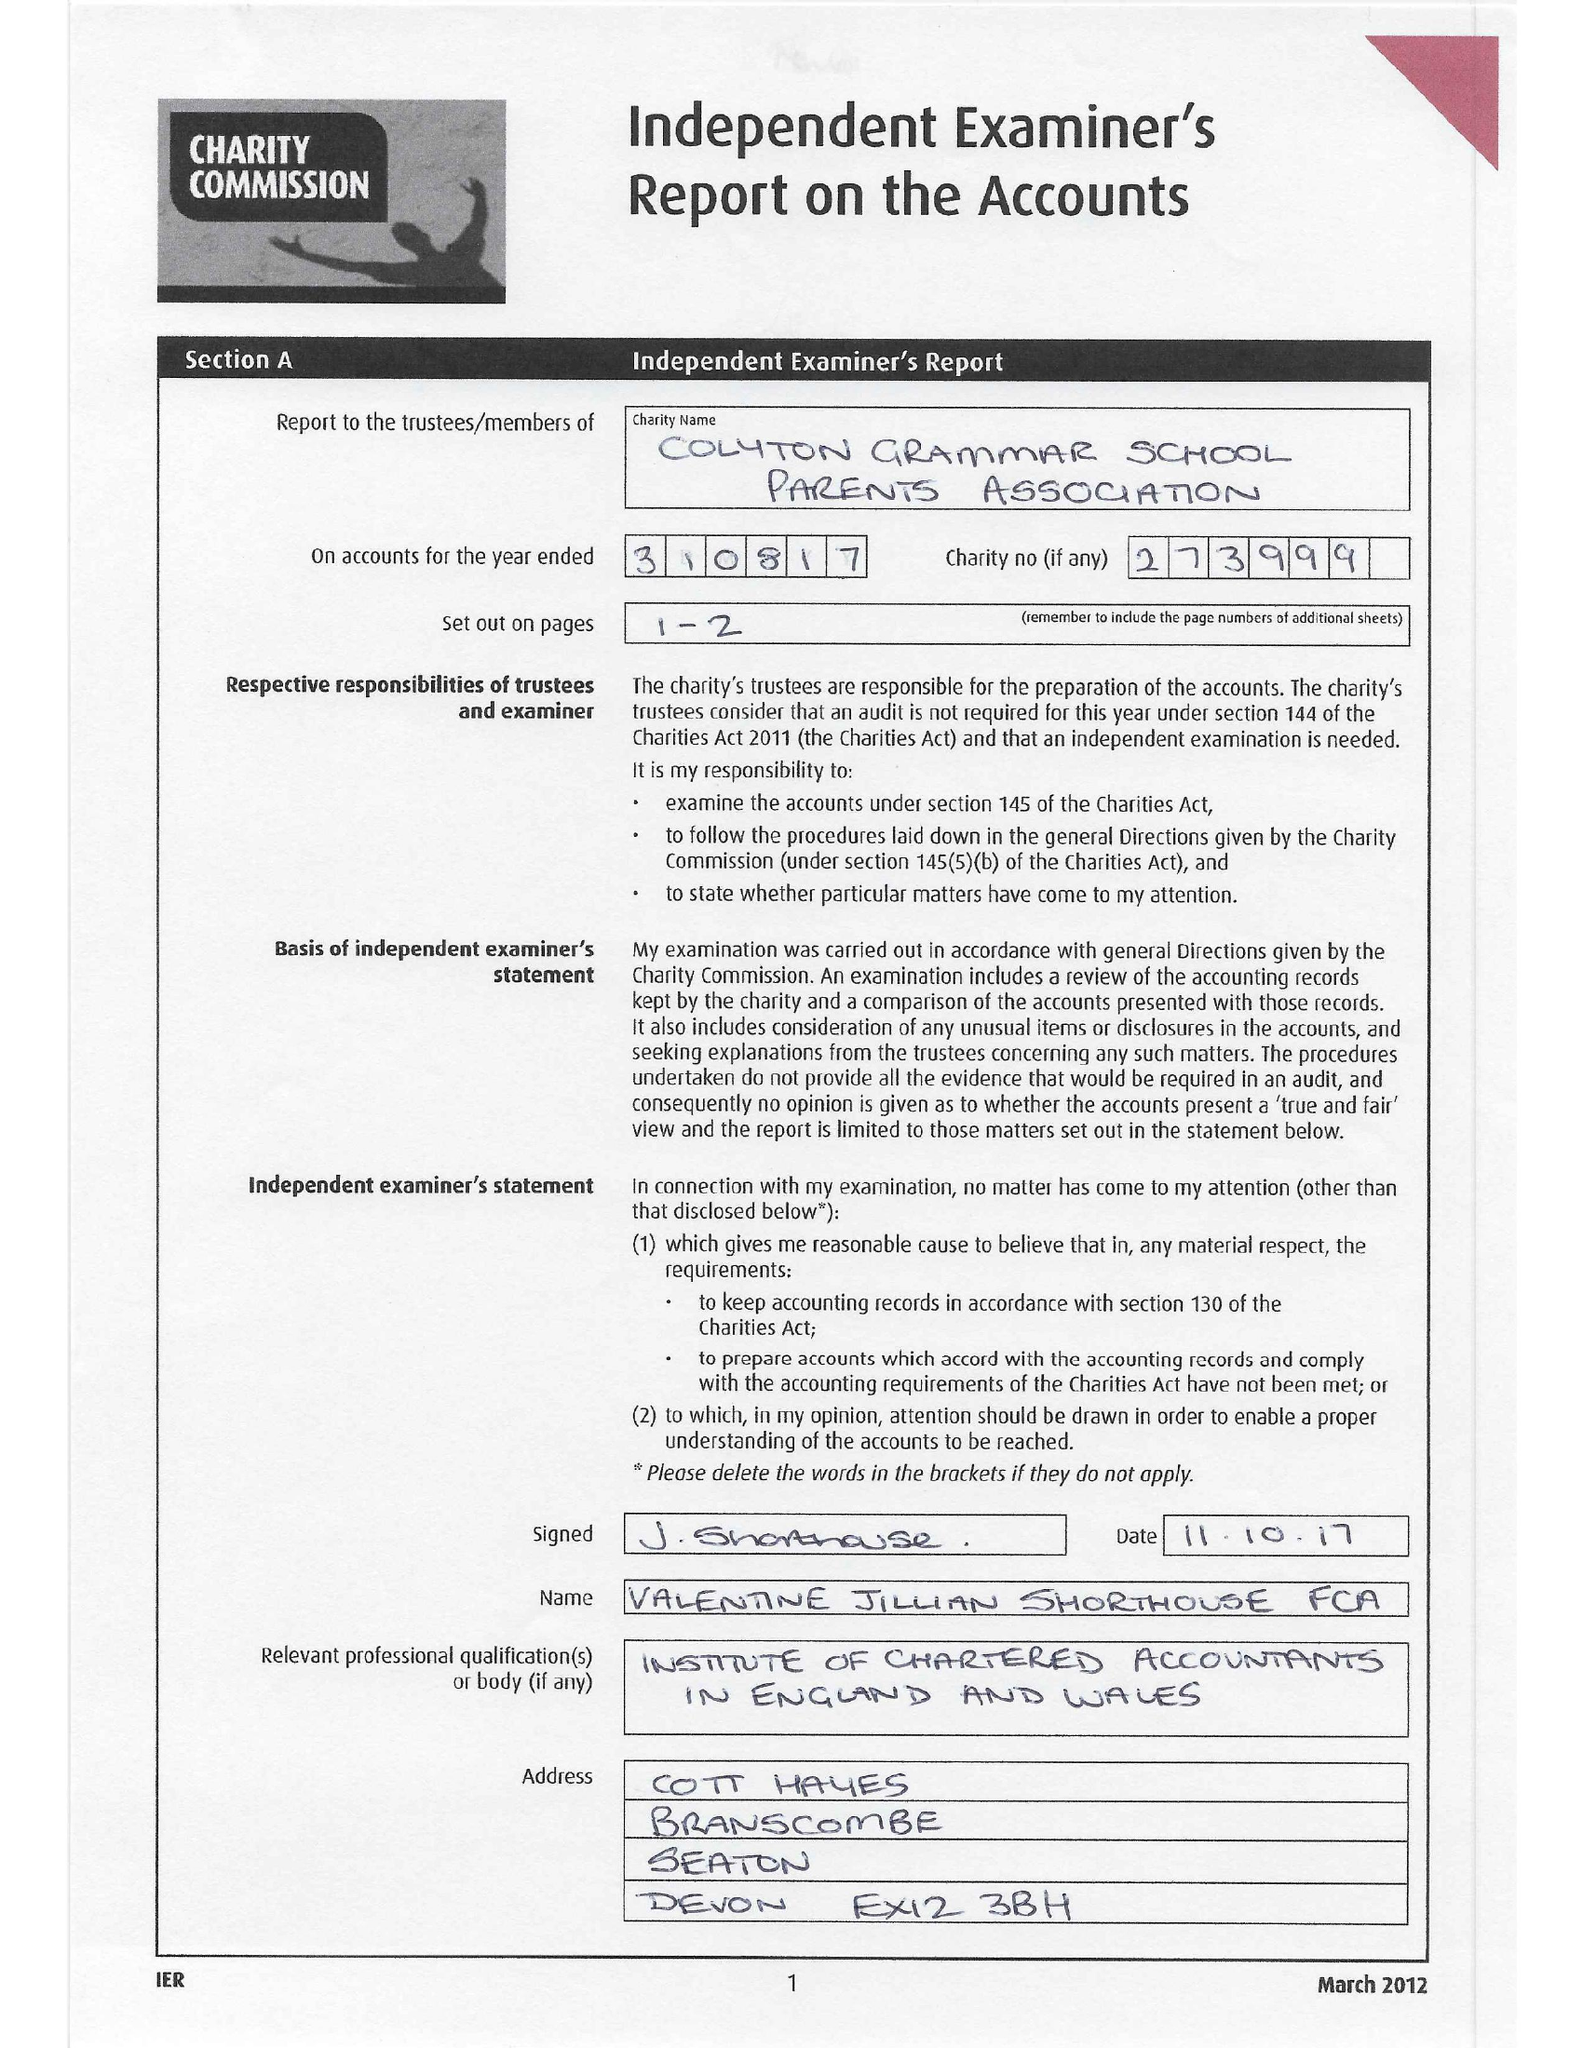What is the value for the charity_name?
Answer the question using a single word or phrase. Colyton Grammar School Parents Association 